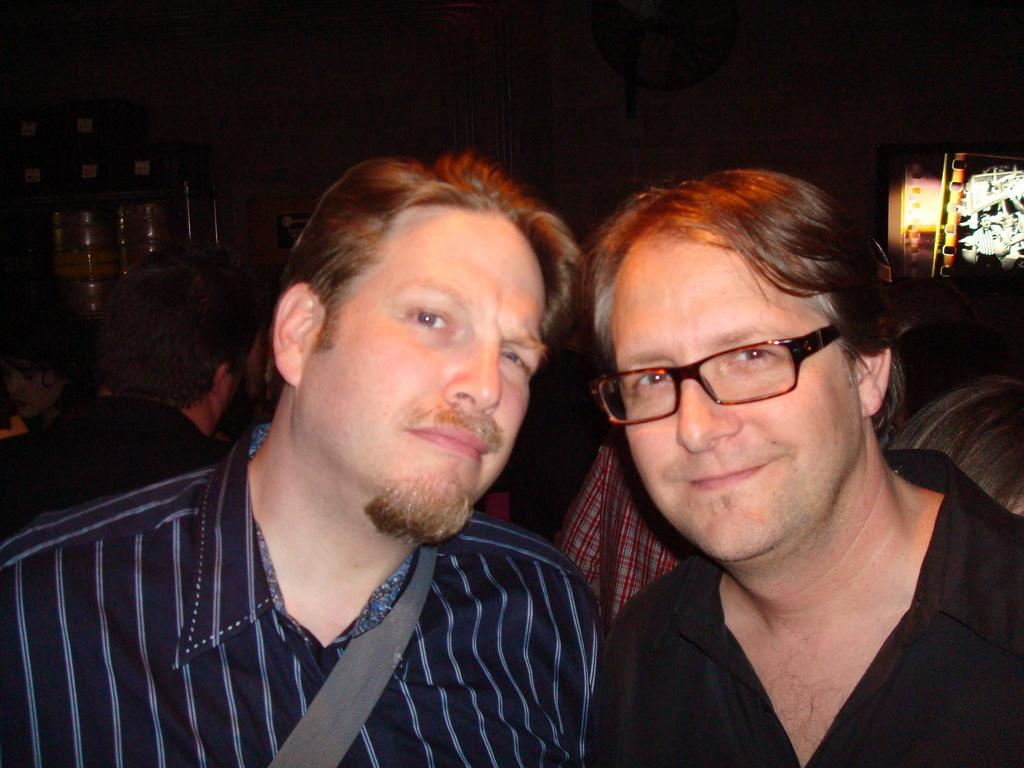How many people are present in the image? There are two persons in the image. Can you describe one of the persons in the image? One of the persons is wearing spectacles. What can be seen in the background of the image? There are other people visible in the background. What type of horn can be seen on the tramp in the image? There is no tramp or horn present in the image. 